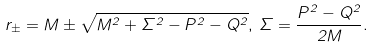<formula> <loc_0><loc_0><loc_500><loc_500>r _ { \pm } = M \pm \sqrt { M ^ { 2 } + \Sigma ^ { 2 } - P ^ { 2 } - Q ^ { 2 } } , \, \Sigma = \frac { P ^ { 2 } - Q ^ { 2 } } { 2 M } .</formula> 